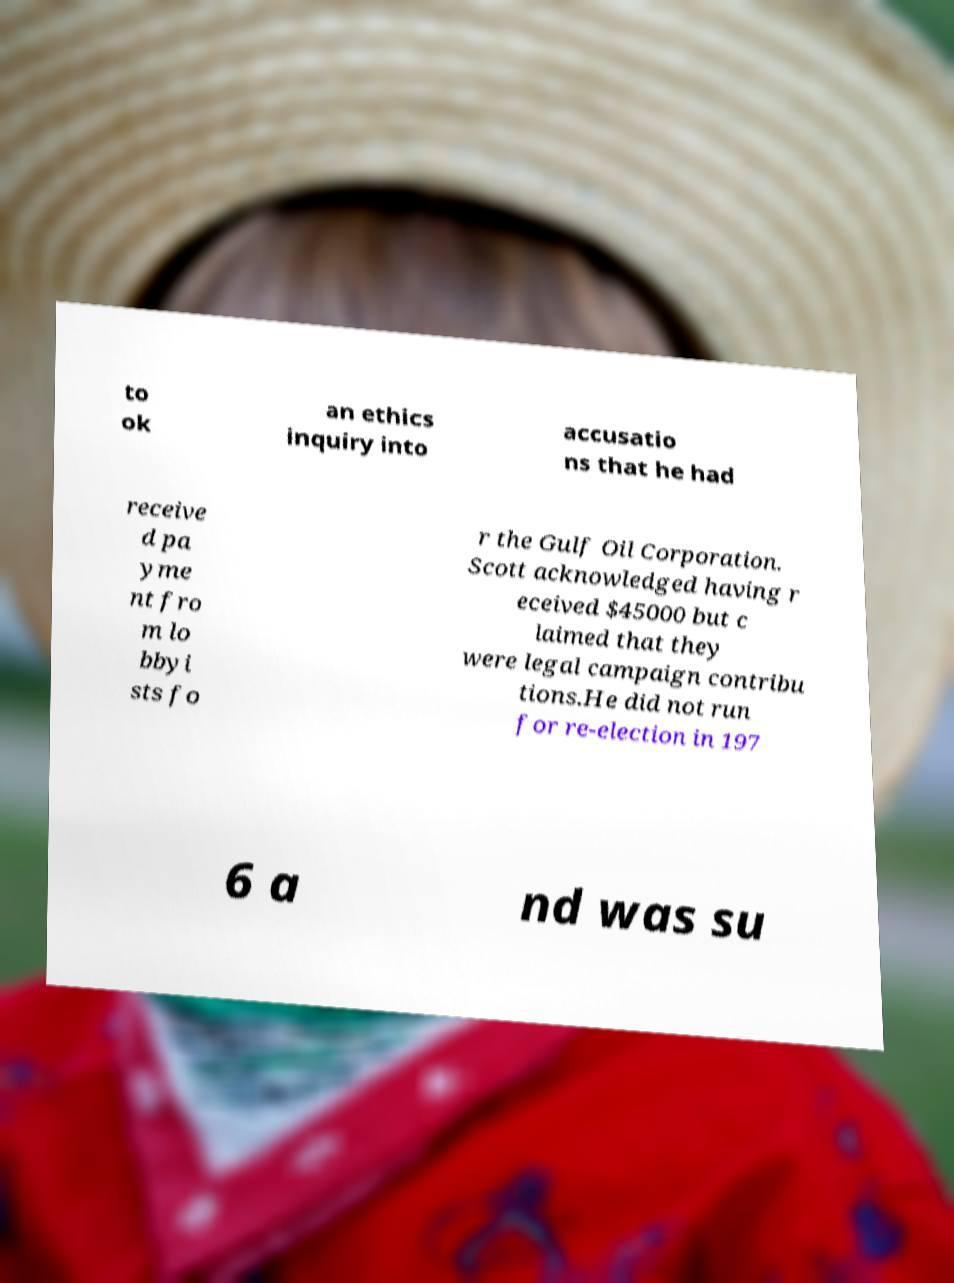Could you assist in decoding the text presented in this image and type it out clearly? to ok an ethics inquiry into accusatio ns that he had receive d pa yme nt fro m lo bbyi sts fo r the Gulf Oil Corporation. Scott acknowledged having r eceived $45000 but c laimed that they were legal campaign contribu tions.He did not run for re-election in 197 6 a nd was su 